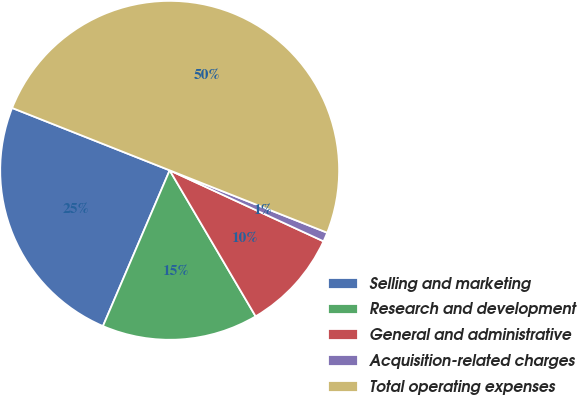<chart> <loc_0><loc_0><loc_500><loc_500><pie_chart><fcel>Selling and marketing<fcel>Research and development<fcel>General and administrative<fcel>Acquisition-related charges<fcel>Total operating expenses<nl><fcel>24.56%<fcel>14.91%<fcel>9.65%<fcel>0.88%<fcel>50.0%<nl></chart> 